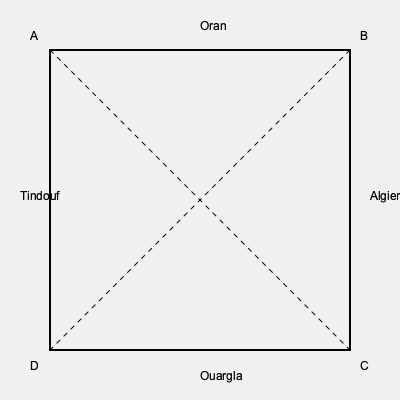You have a square map of Algeria's historical provinces. If you fold the map along both diagonals, which two provinces will overlap completely? To solve this problem, we need to follow these steps:

1. Understand the map layout:
   - The map is square-shaped with four corners labeled A, B, C, and D.
   - Four historical provinces are marked: Oran, Algiers, Ouargla, and Tindouf.
   - The diagonals are shown as dashed lines connecting opposite corners.

2. Visualize the folding process:
   - Folding along the first diagonal (AC) will bring corners A and C together.
   - Folding along the second diagonal (BD) will bring corners B and D together.

3. Analyze the overlapping:
   - When both folds are complete, all four corners will meet at the center.
   - The provinces located at opposite corners will overlap completely.

4. Identify the overlapping provinces:
   - Oran is located near corner A, and Ouargla is located near corner C.
   - Tindouf is located near corner D, and Algiers is located near corner B.

5. Conclude:
   - The provinces that will overlap completely are Oran and Ouargla.

This folding exercise reflects the geographical diversity of Algeria, connecting the coastal region of Oran with the Saharan region of Ouargla, symbolizing the unity of the country across its varied landscapes.
Answer: Oran and Ouargla 